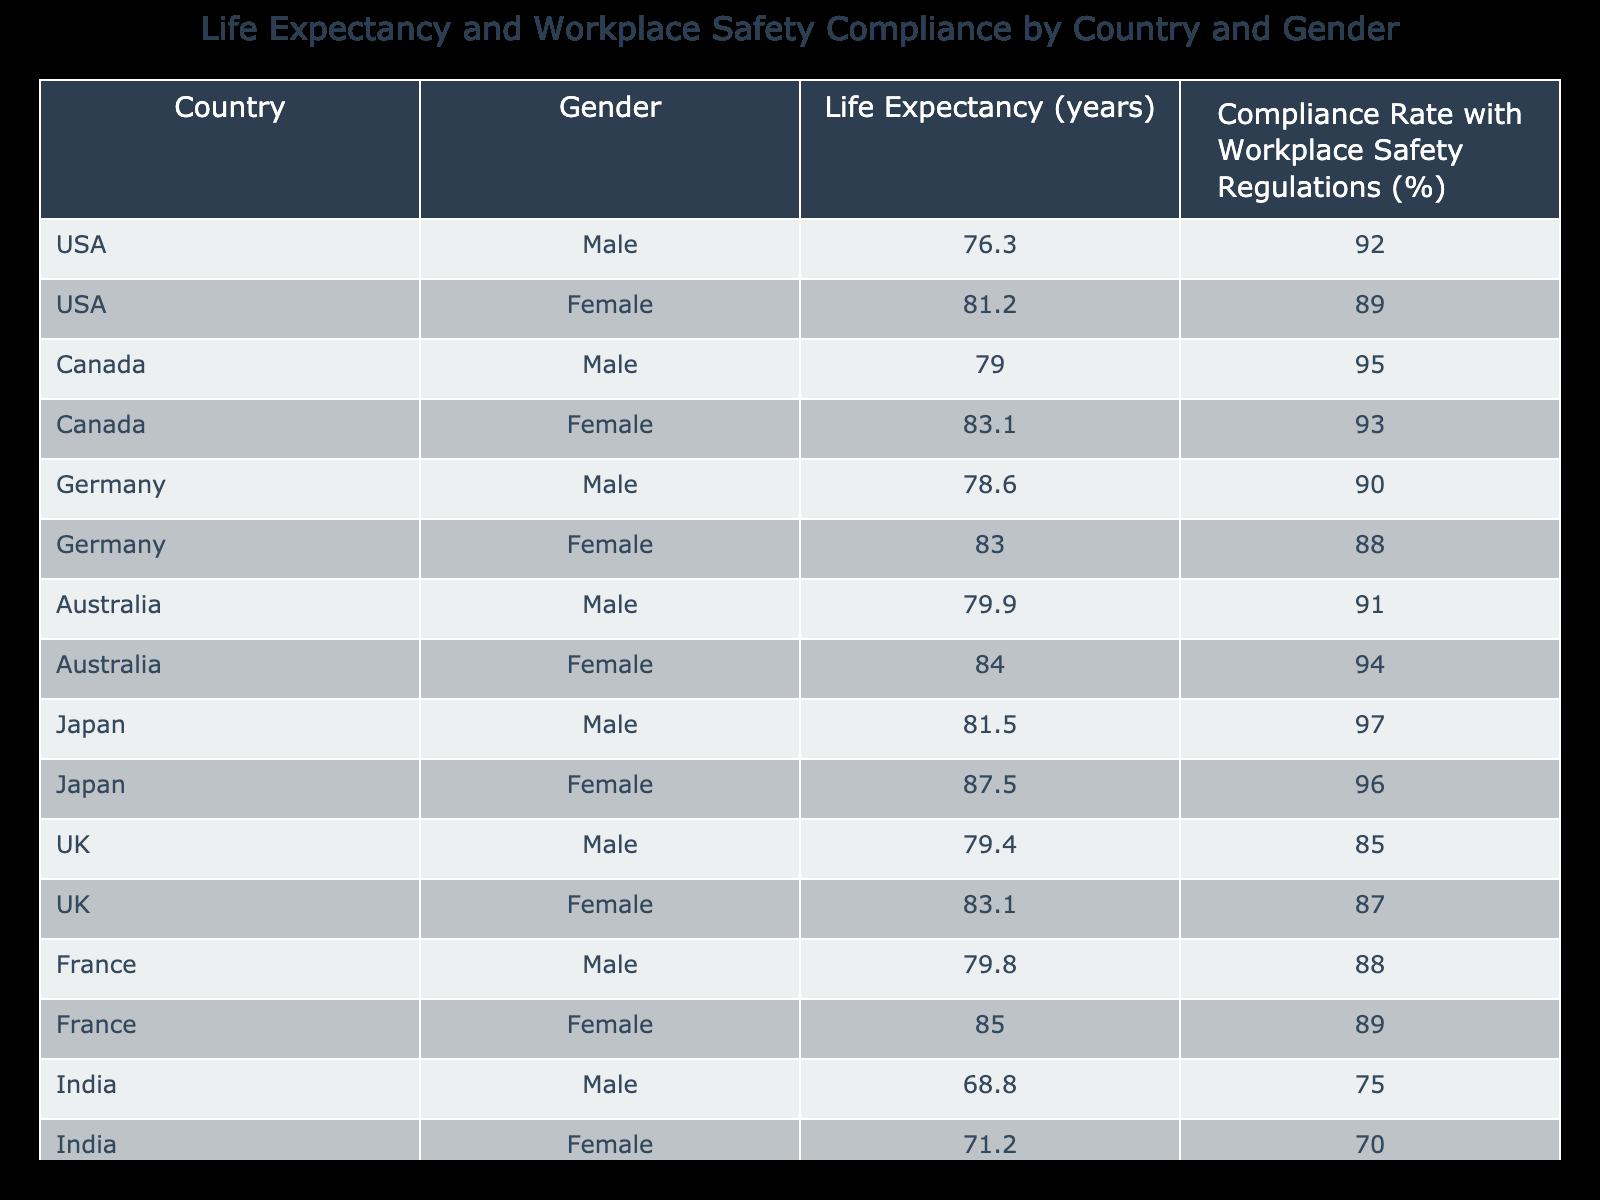What is the life expectancy for females in Japan? The table shows that the life expectancy for females in Japan is listed directly as 87.5 years.
Answer: 87.5 years Which country has the highest life expectancy for males? By reviewing the male life expectancy values for each country, Japan has the highest value at 81.5 years while the others are lower.
Answer: Japan What is the compliance rate with workplace safety regulations for Canadian females? The table indicates that the compliance rate with workplace safety regulations for Canadian females is 93%.
Answer: 93% Is the life expectancy for males in the UK greater than that in India? For this, we check the life expectancy for males: UK is 79.4 years and India is 68.8 years. Since 79.4 is greater than 68.8, the answer is yes.
Answer: Yes What is the average life expectancy for females across all countries? To find the average, sum the life expectancy values for females: 81.2 (USA) + 83.1 (Canada) + 83.0 (Germany) + 84.0 (Australia) + 87.5 (Japan) + 83.1 (UK) + 85.0 (France) + 71.2 (India) + 79.2 (Brazil) =  5 values adding up to 466. The average is 466/9 ≈ 74.0 years.
Answer: Approx. 82.9 years What is the difference in compliance rates between males and females in Germany? From the table, the compliance rate for German males is 90% and for females is 88%. The difference is therefore 90% - 88% = 2%.
Answer: 2% Which country has the lowest compliance rate for males while maintaining a life expectancy over 75 years? Checking the table, the compliance rate for Indian males is 75% and they have a life expectancy of 68.8 years, which doesn't meet the criteria; however, Brazil has a 78% compliance rate and a life expectancy of 74.7 years, and the next highest compliance rate for males is 85% in the UK, therefore the lowest remaining compliance rate with a life expectancy over 75 is Brazil.
Answer: Brazil Is female life expectancy in France greater than the average life expectancy of all females? First, we find the average female life expectancy as calculated earlier (approx. 82.9 years) and compare it to France's female life expectancy of 85.0 years, since 85.0 is greater than 82.9, the answer is yes.
Answer: Yes 